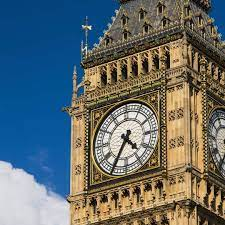What do you see happening in this image? The image captures Big Ben, an iconic symbol of London and the United Kingdom. Constructed with an intricate Gothic Revival style, this clock tower's dark stone and gilded details gleam under the brilliant blue sky. Its clock face shows 2:30, serving as a reliable timekeeper since 1859. This image, taken from a low angle, emphasizes Big Ben's towering and majestic presence, which stands not only as a functional piece but has also witnessed numerous historical events, resonating with locals and tourists alike. 